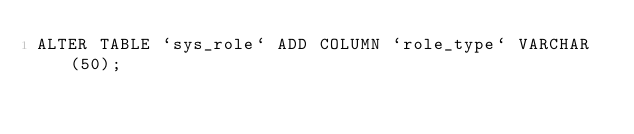<code> <loc_0><loc_0><loc_500><loc_500><_SQL_>ALTER TABLE `sys_role` ADD COLUMN `role_type` VARCHAR (50);
</code> 